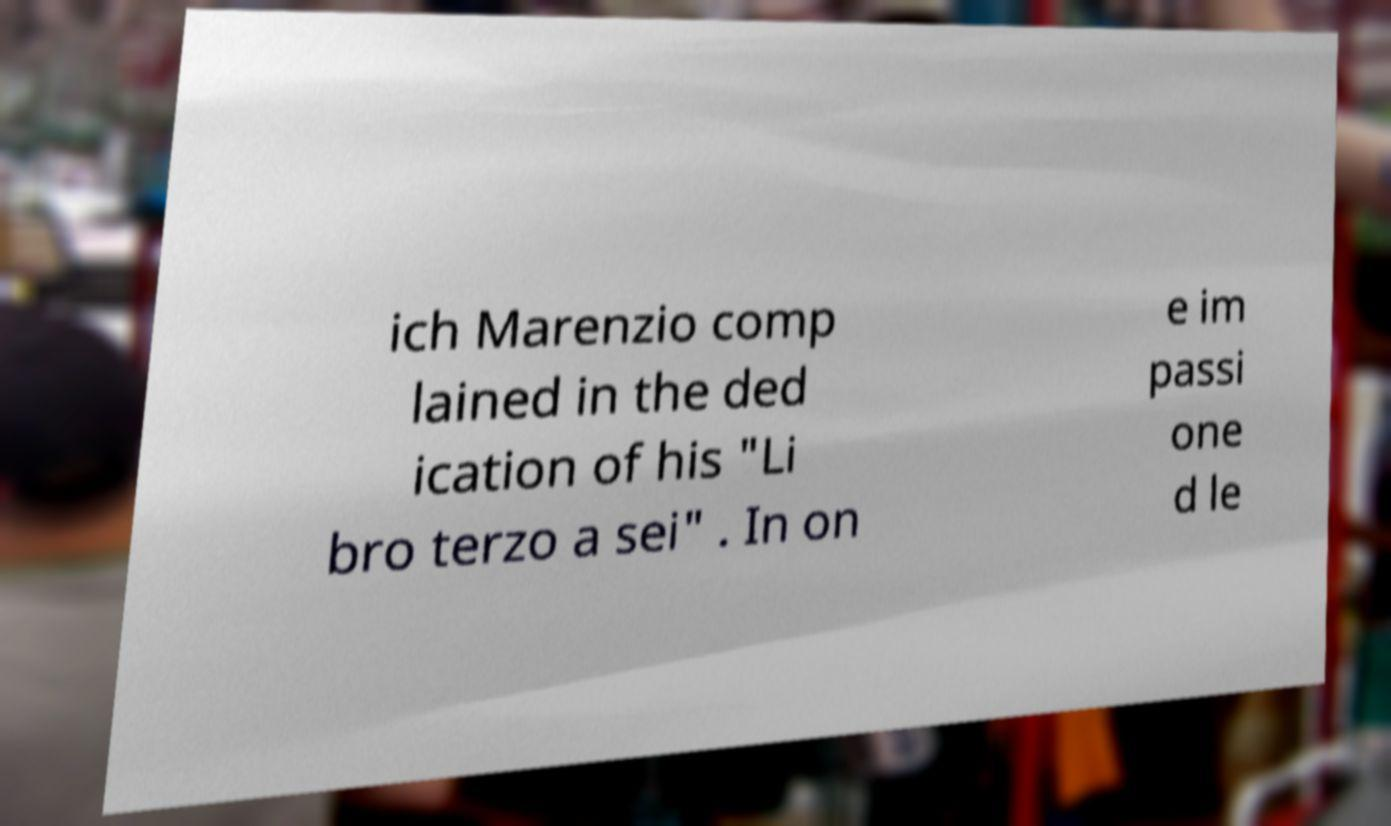Can you accurately transcribe the text from the provided image for me? ich Marenzio comp lained in the ded ication of his "Li bro terzo a sei" . In on e im passi one d le 